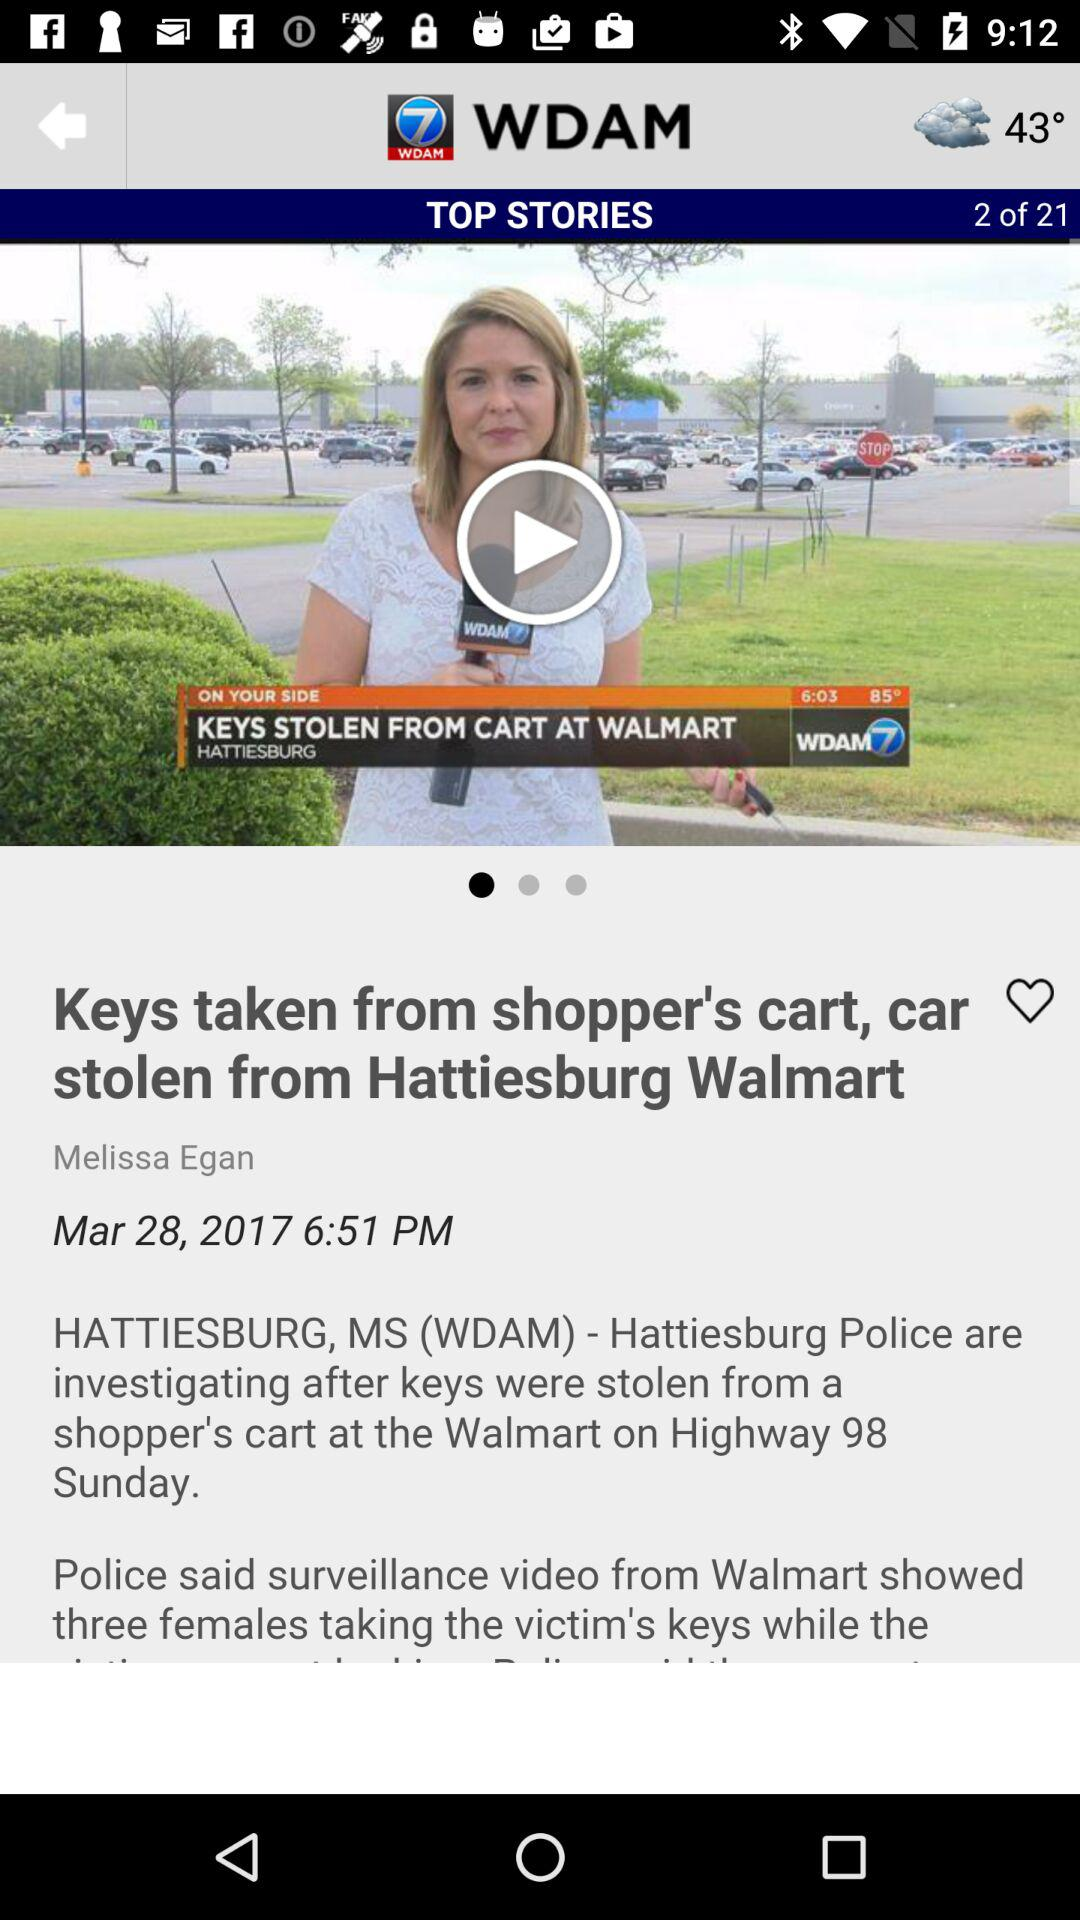What is the temperature? The temperatures are 43° and 85°. 